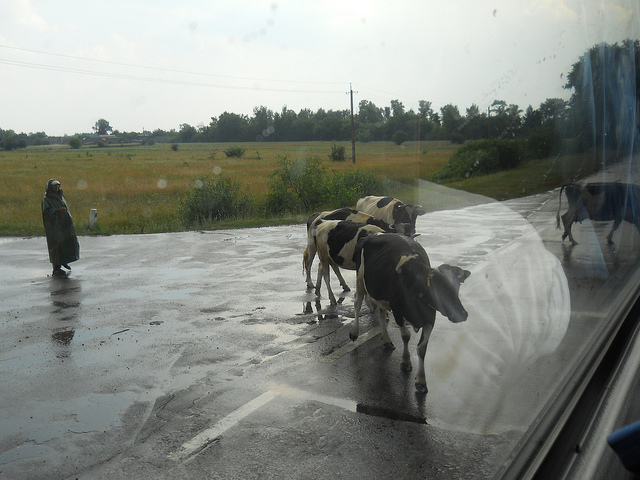Can you describe the area surrounding the cows? The cows are surrounded by a serene rural landscape with lush green fields extending into the distance. It creates a peaceful countryside scene, typical of areas where agriculture and livestock are part of the local way of life. 